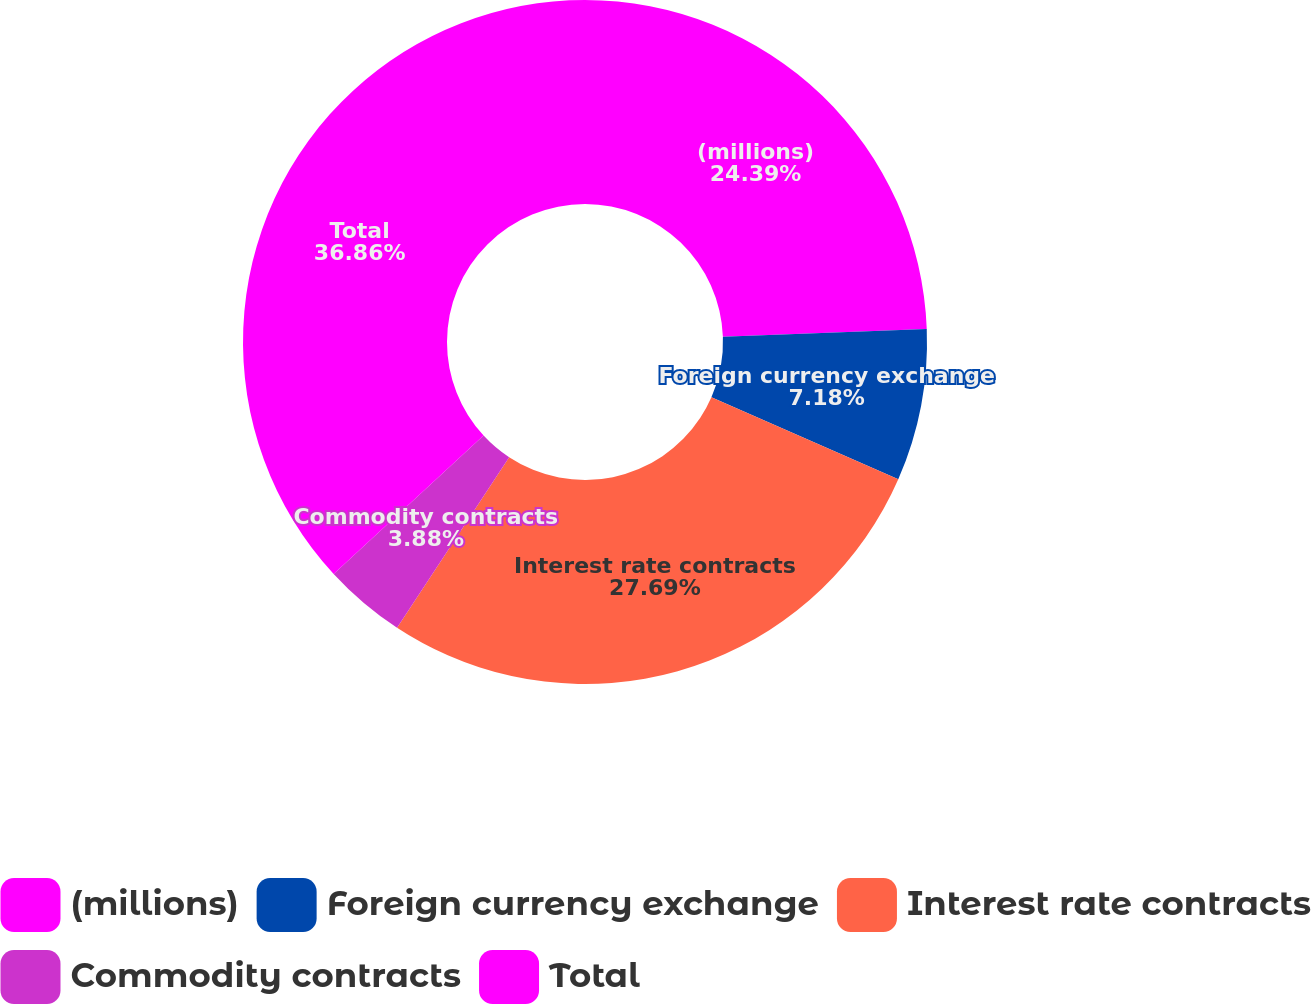Convert chart to OTSL. <chart><loc_0><loc_0><loc_500><loc_500><pie_chart><fcel>(millions)<fcel>Foreign currency exchange<fcel>Interest rate contracts<fcel>Commodity contracts<fcel>Total<nl><fcel>24.39%<fcel>7.18%<fcel>27.69%<fcel>3.88%<fcel>36.86%<nl></chart> 